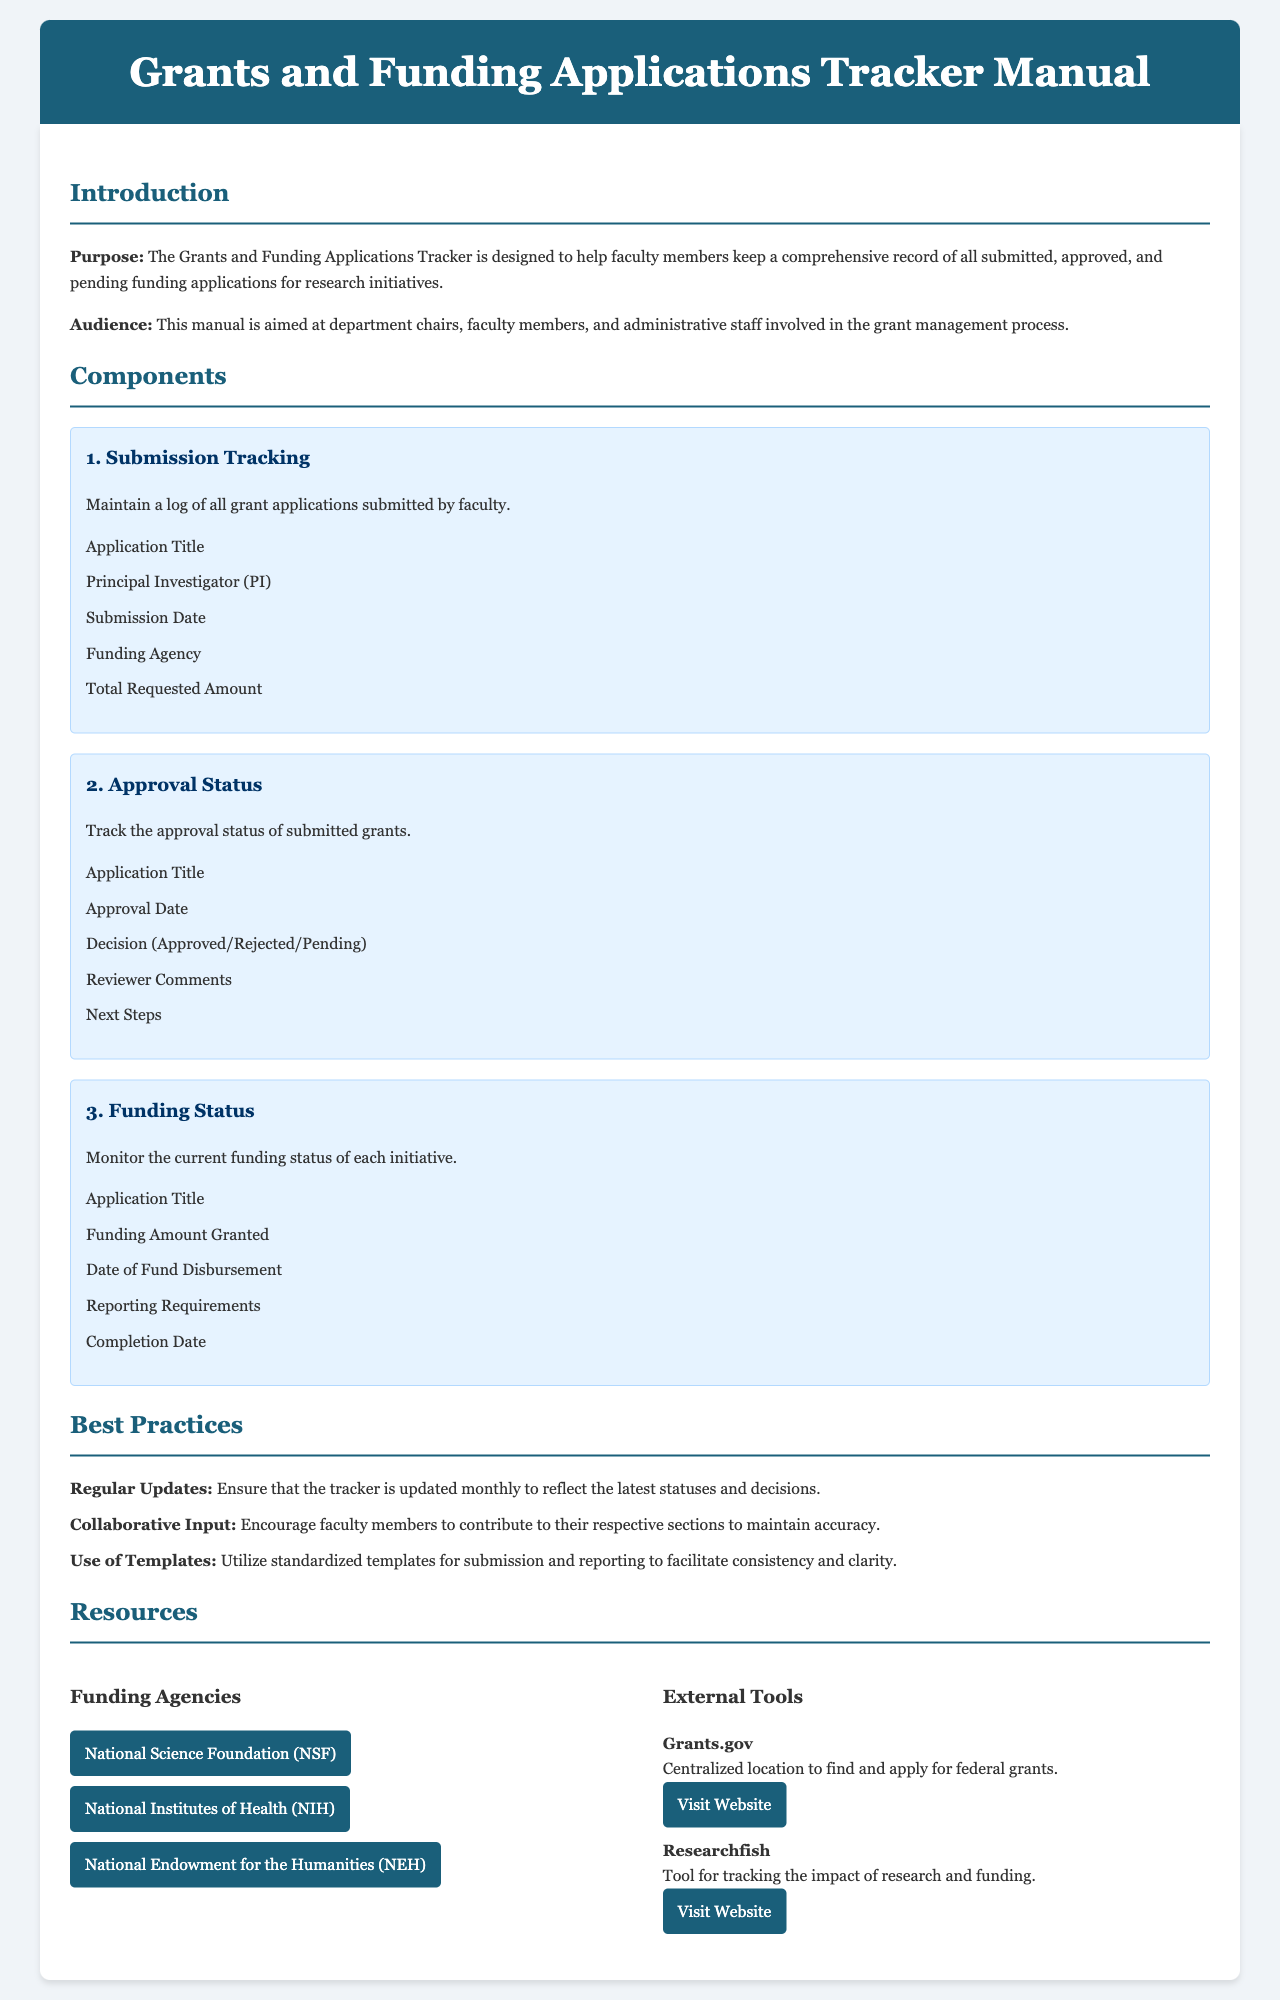What is the purpose of the Grants and Funding Applications Tracker? The purpose of the tracker is to help faculty members keep a comprehensive record of all submitted, approved, and pending funding applications for research initiatives.
Answer: To keep a comprehensive record of all submitted, approved, and pending funding applications Who is the audience of this manual? The audience includes department chairs, faculty members, and administrative staff involved in the grant management process.
Answer: Department chairs, faculty members, and administrative staff What are the components of submission tracking? The components include Application Title, Principal Investigator (PI), Submission Date, Funding Agency, and Total Requested Amount.
Answer: Application Title, Principal Investigator (PI), Submission Date, Funding Agency, Total Requested Amount How often should the tracker be updated? The document states that the tracker should be updated monthly.
Answer: Monthly What is the name of one funding agency listed in the resources section? The document lists several funding agencies; one of them is the National Science Foundation.
Answer: National Science Foundation (NSF) What is the next step after a grant application is rejected according to the approval status section? The document specifies a section for "Next Steps," where details regarding subsequent actions can be found.
Answer: Next Steps What should faculty members do to maintain accuracy in the tracker? Faculty members are encouraged to provide collaborative input to maintain accuracy.
Answer: Collaborative input Which tool is mentioned for tracking the impact of research and funding? Researchfish is mentioned as a tool for tracking the impact of research and funding.
Answer: Researchfish 